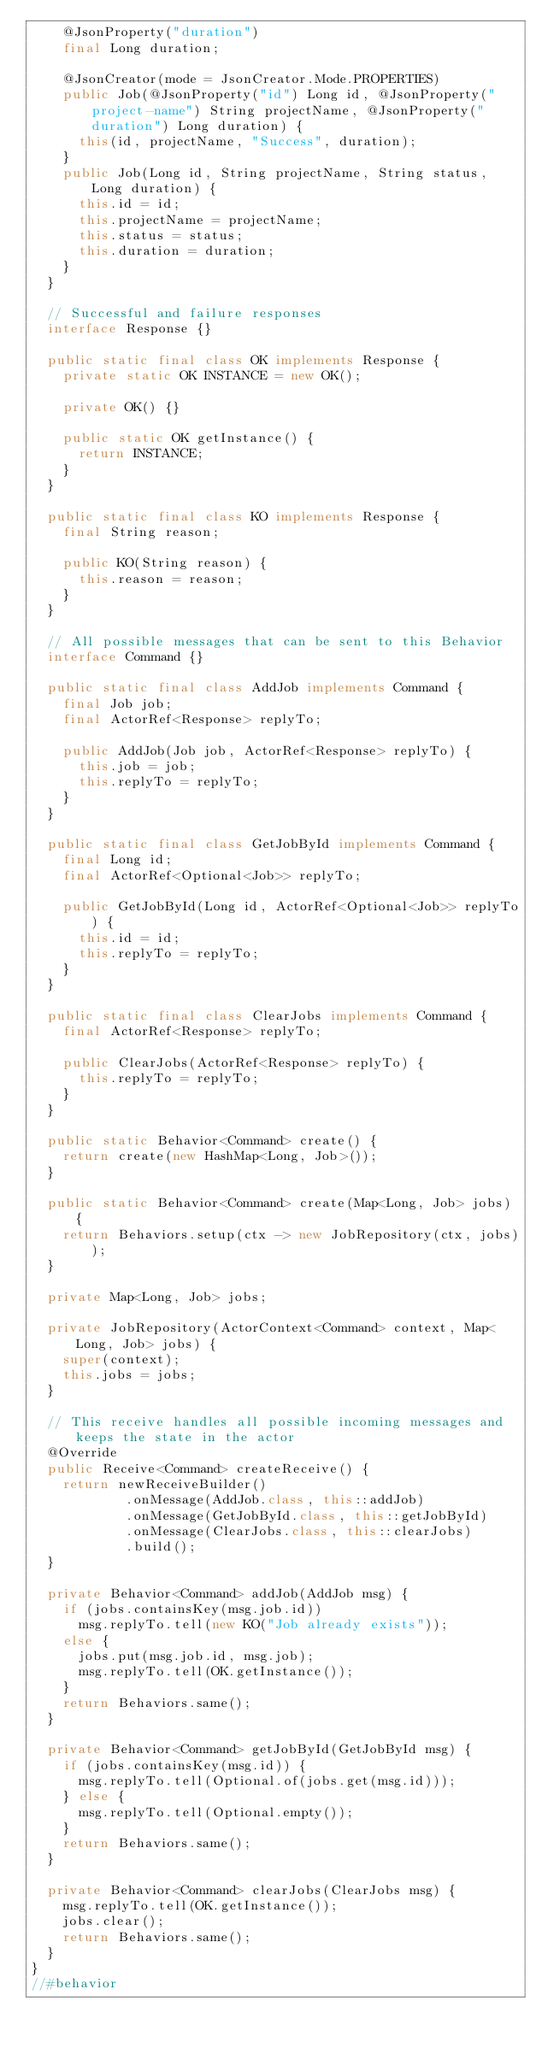<code> <loc_0><loc_0><loc_500><loc_500><_Java_>    @JsonProperty("duration")
    final Long duration;

    @JsonCreator(mode = JsonCreator.Mode.PROPERTIES)
    public Job(@JsonProperty("id") Long id, @JsonProperty("project-name") String projectName, @JsonProperty("duration") Long duration) {
      this(id, projectName, "Success", duration);
    }
    public Job(Long id, String projectName, String status, Long duration) {
      this.id = id;
      this.projectName = projectName;
      this.status = status;
      this.duration = duration;
    }
  }

  // Successful and failure responses
  interface Response {}

  public static final class OK implements Response {
    private static OK INSTANCE = new OK();

    private OK() {}

    public static OK getInstance() {
      return INSTANCE;
    }
  }

  public static final class KO implements Response {
    final String reason;

    public KO(String reason) {
      this.reason = reason;
    }
  }

  // All possible messages that can be sent to this Behavior
  interface Command {}

  public static final class AddJob implements Command {
    final Job job;
    final ActorRef<Response> replyTo;

    public AddJob(Job job, ActorRef<Response> replyTo) {
      this.job = job;
      this.replyTo = replyTo;
    }
  }

  public static final class GetJobById implements Command {
    final Long id;
    final ActorRef<Optional<Job>> replyTo;

    public GetJobById(Long id, ActorRef<Optional<Job>> replyTo) {
      this.id = id;
      this.replyTo = replyTo;
    }
  }

  public static final class ClearJobs implements Command {
    final ActorRef<Response> replyTo;

    public ClearJobs(ActorRef<Response> replyTo) {
      this.replyTo = replyTo;
    }
  }

  public static Behavior<Command> create() {
    return create(new HashMap<Long, Job>());
  }

  public static Behavior<Command> create(Map<Long, Job> jobs) {
    return Behaviors.setup(ctx -> new JobRepository(ctx, jobs));
  }

  private Map<Long, Job> jobs;

  private JobRepository(ActorContext<Command> context, Map<Long, Job> jobs) {
    super(context);
    this.jobs = jobs;
  }

  // This receive handles all possible incoming messages and keeps the state in the actor
  @Override
  public Receive<Command> createReceive() {
    return newReceiveBuilder()
            .onMessage(AddJob.class, this::addJob)
            .onMessage(GetJobById.class, this::getJobById)
            .onMessage(ClearJobs.class, this::clearJobs)
            .build();
  }

  private Behavior<Command> addJob(AddJob msg) {
    if (jobs.containsKey(msg.job.id))
      msg.replyTo.tell(new KO("Job already exists"));
    else {
      jobs.put(msg.job.id, msg.job);
      msg.replyTo.tell(OK.getInstance());
    }
    return Behaviors.same();
  }

  private Behavior<Command> getJobById(GetJobById msg) {
    if (jobs.containsKey(msg.id)) {
      msg.replyTo.tell(Optional.of(jobs.get(msg.id)));
    } else {
      msg.replyTo.tell(Optional.empty());
    }
    return Behaviors.same();
  }

  private Behavior<Command> clearJobs(ClearJobs msg) {
    msg.replyTo.tell(OK.getInstance());
    jobs.clear();
    return Behaviors.same();
  }
}
//#behavior</code> 